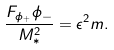<formula> <loc_0><loc_0><loc_500><loc_500>\frac { F _ { \phi _ { + } } \phi _ { - } } { M _ { * } ^ { 2 } } = \epsilon ^ { 2 } m .</formula> 